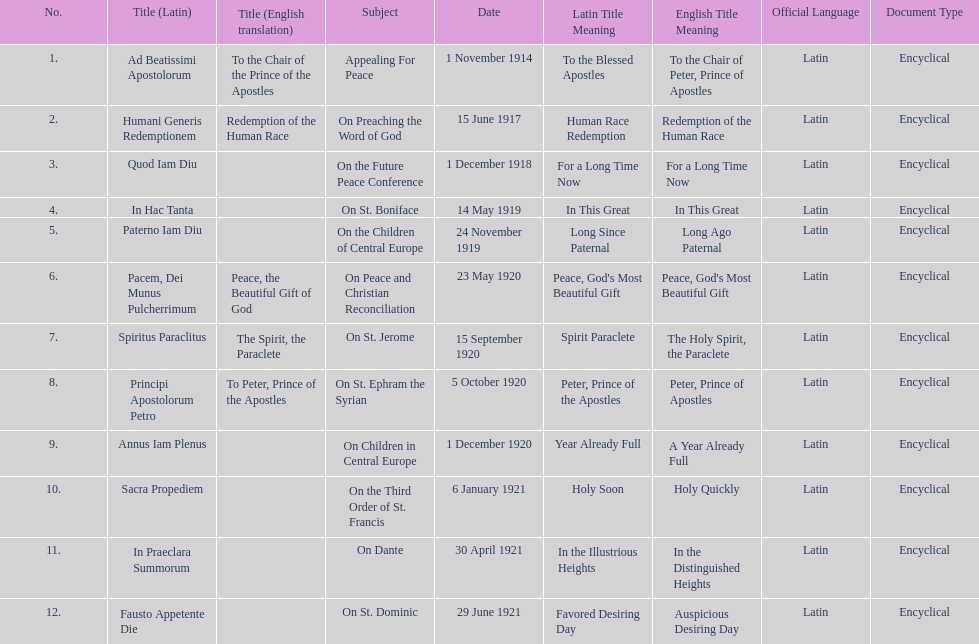What are the number of titles with a date of november? 2. 